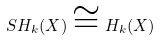Convert formula to latex. <formula><loc_0><loc_0><loc_500><loc_500>S H _ { k } ( X ) \cong H _ { k } ( X )</formula> 